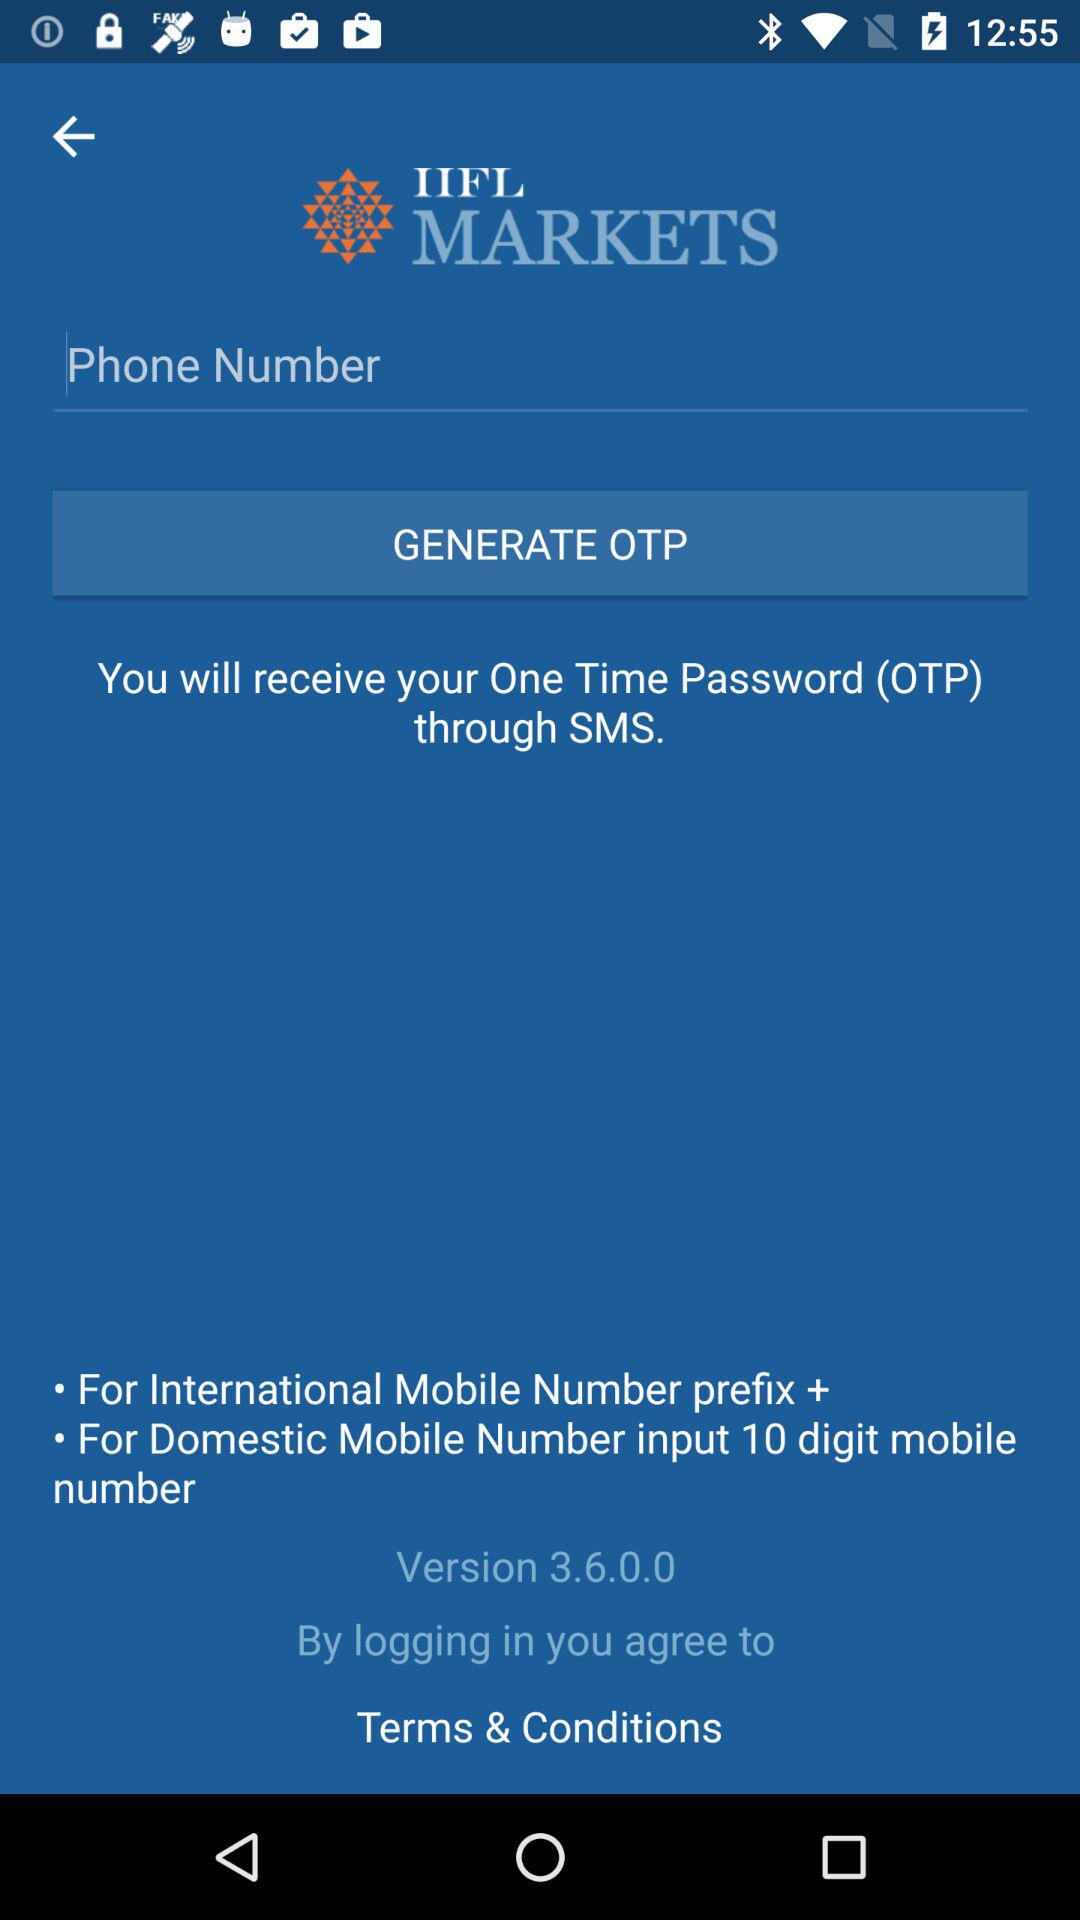How many digits should be entered for domestic mobile numbers? There should be 10 digits entered for domestic mobile numbers. 